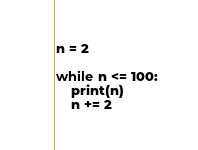Convert code to text. <code><loc_0><loc_0><loc_500><loc_500><_Python_>n = 2

while n <= 100:
    print(n)
    n += 2</code> 